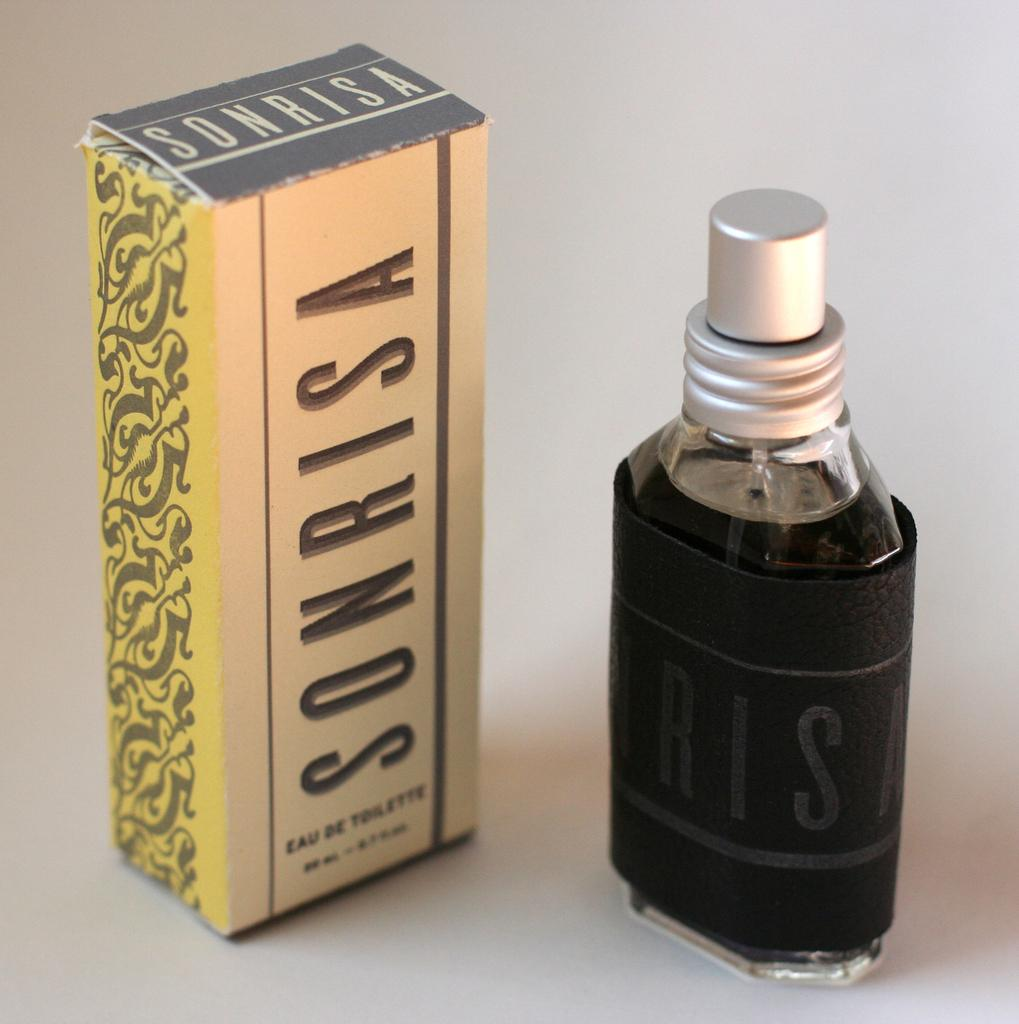<image>
Share a concise interpretation of the image provided. sonrisa cologne box with the bottle standing next to it. 